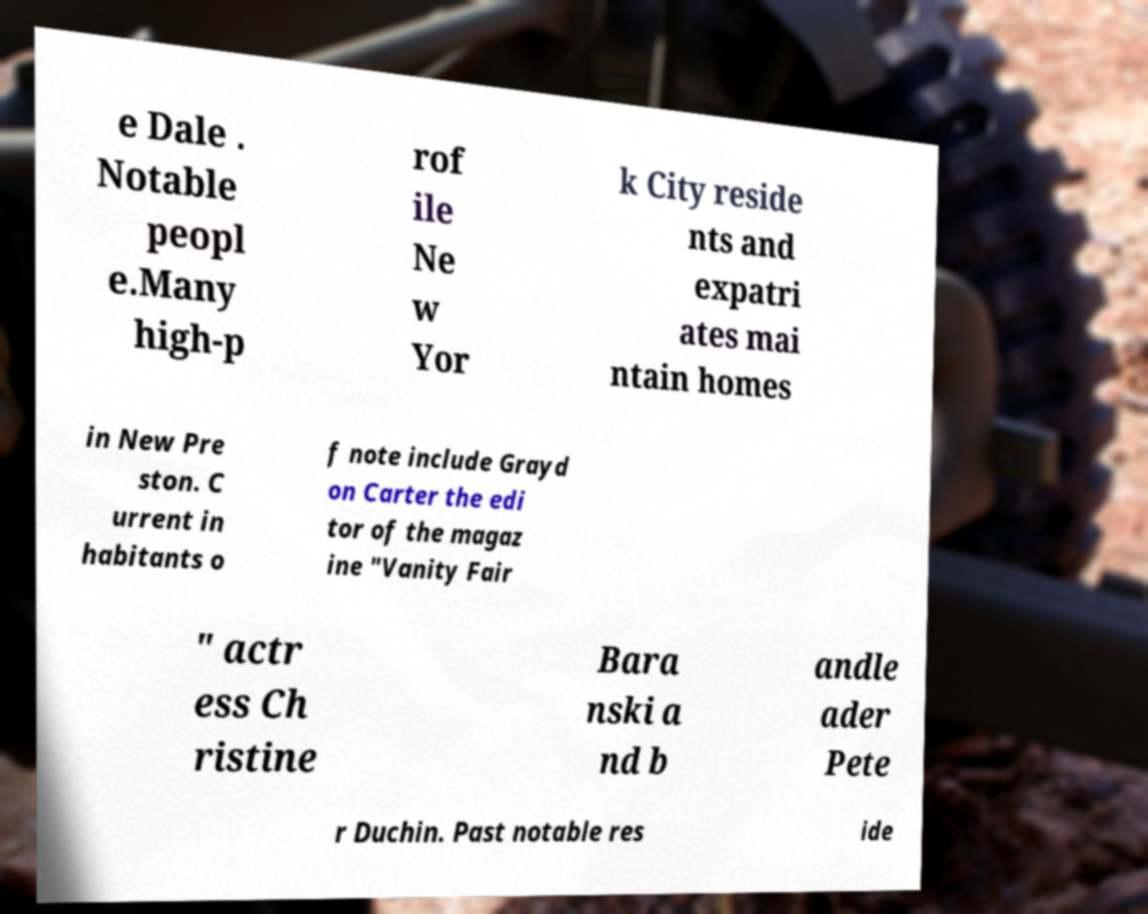Could you extract and type out the text from this image? e Dale . Notable peopl e.Many high-p rof ile Ne w Yor k City reside nts and expatri ates mai ntain homes in New Pre ston. C urrent in habitants o f note include Grayd on Carter the edi tor of the magaz ine "Vanity Fair " actr ess Ch ristine Bara nski a nd b andle ader Pete r Duchin. Past notable res ide 